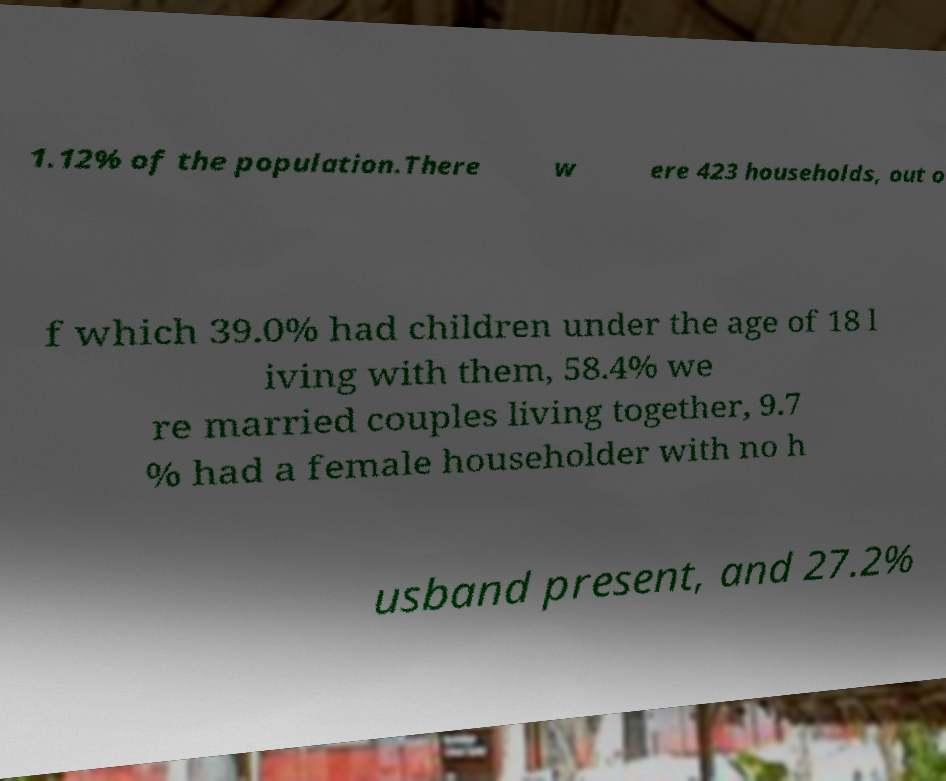Could you assist in decoding the text presented in this image and type it out clearly? 1.12% of the population.There w ere 423 households, out o f which 39.0% had children under the age of 18 l iving with them, 58.4% we re married couples living together, 9.7 % had a female householder with no h usband present, and 27.2% 